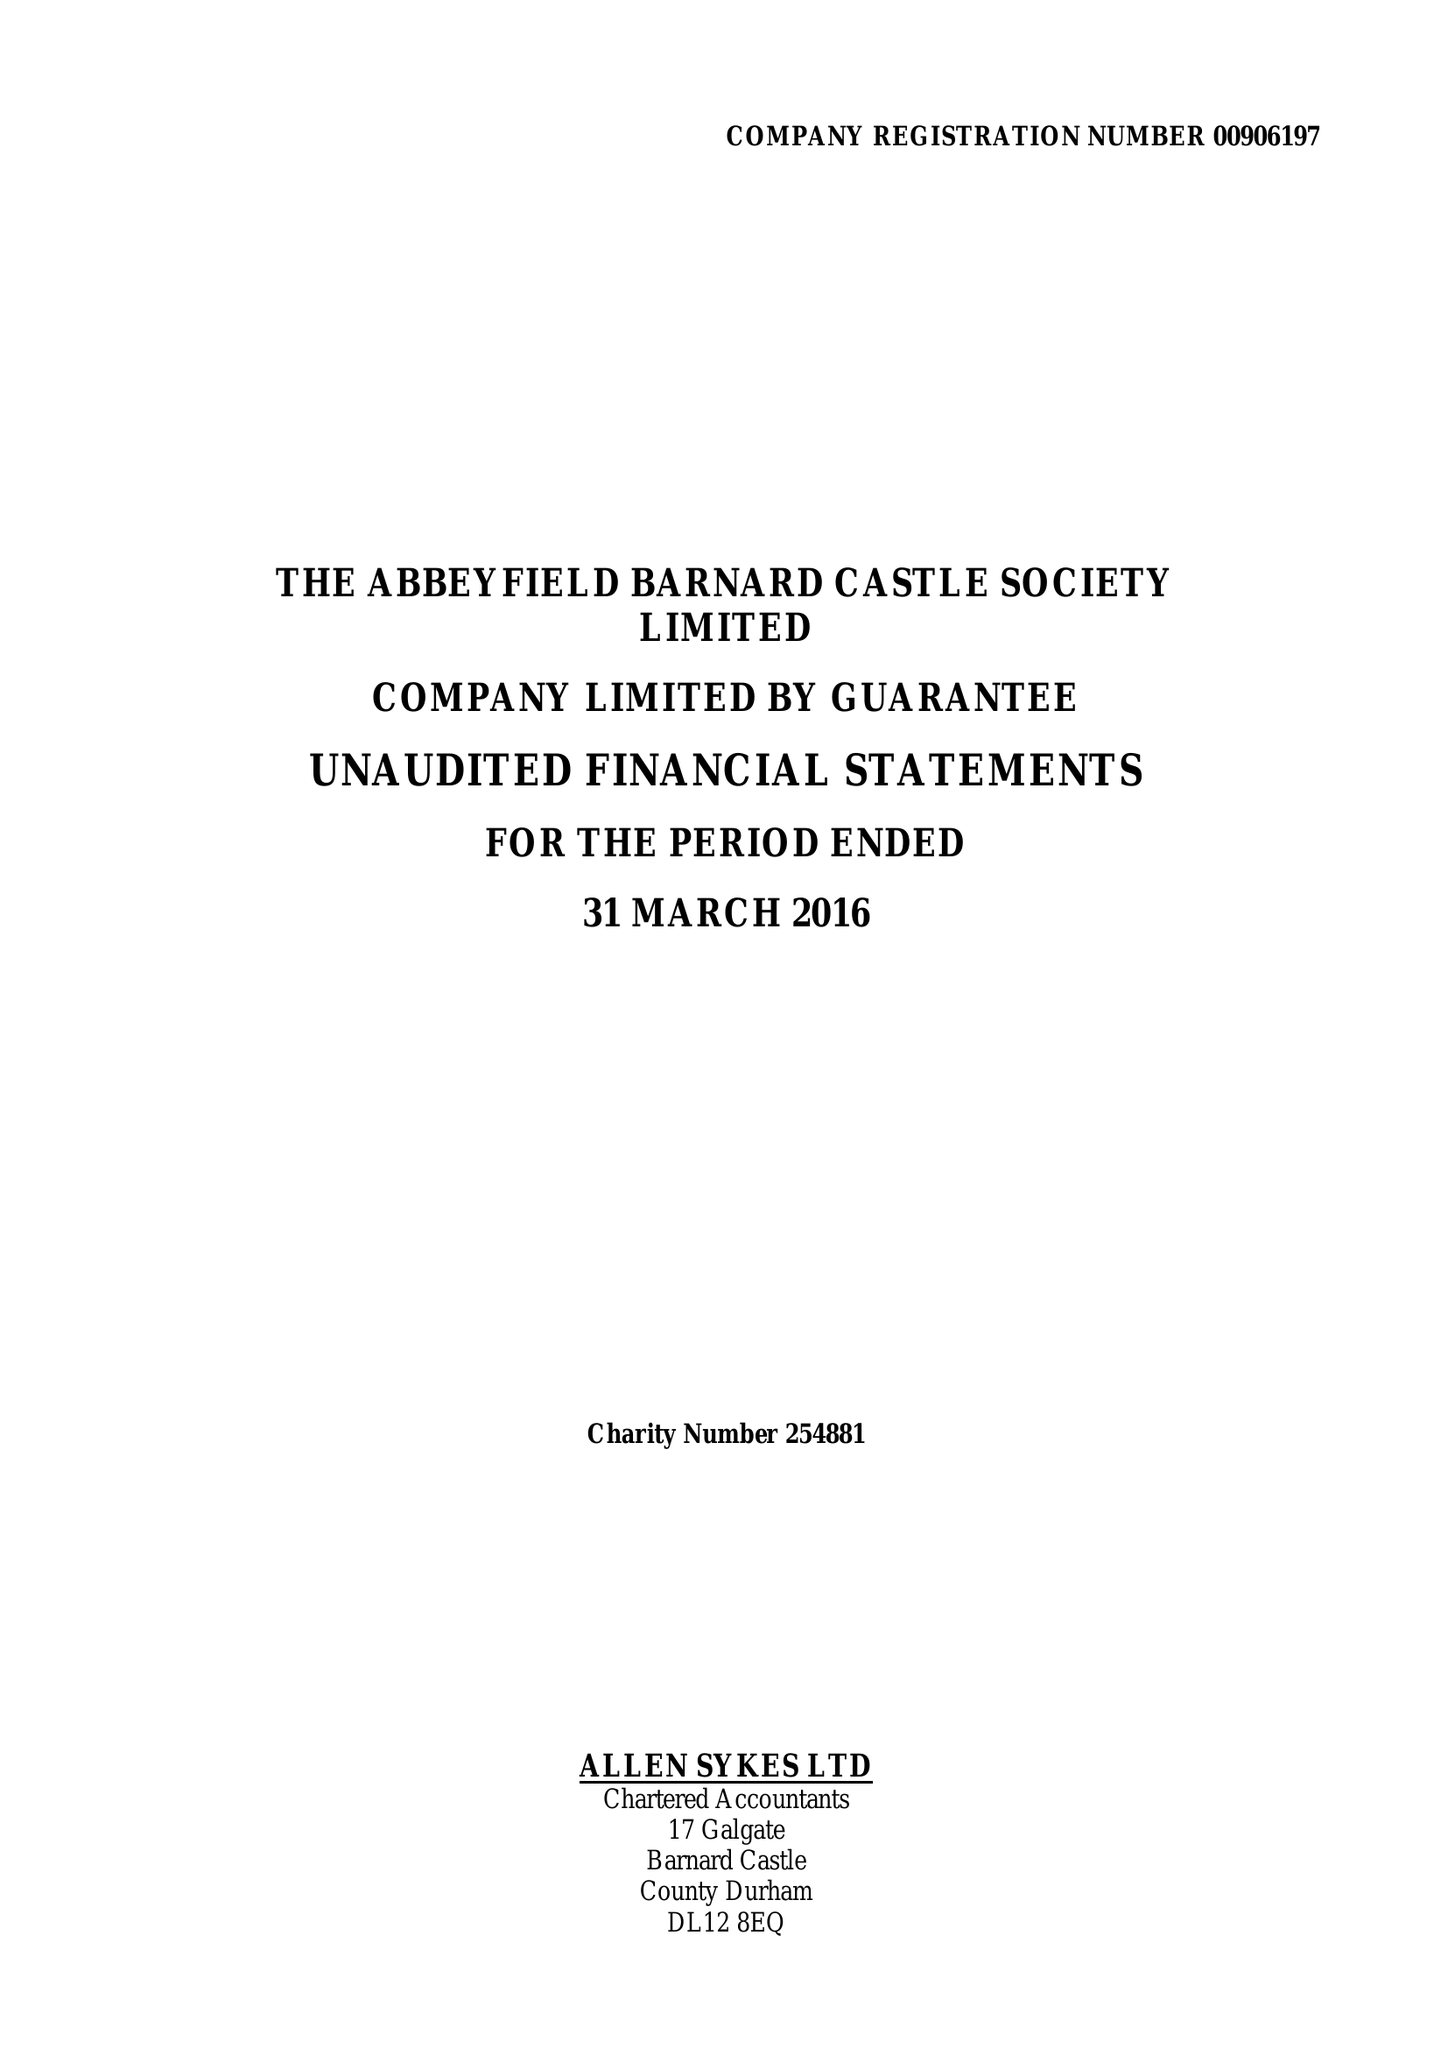What is the value for the income_annually_in_british_pounds?
Answer the question using a single word or phrase. 155030.00 